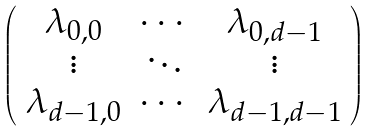<formula> <loc_0><loc_0><loc_500><loc_500>\left ( \begin{array} { c c c } \lambda _ { 0 , 0 } & \cdots & \lambda _ { 0 , d - 1 } \\ \vdots & \ddots & \vdots \\ \lambda _ { d - 1 , 0 } & \cdots & \lambda _ { d - 1 , d - 1 } \\ \end{array} \right )</formula> 